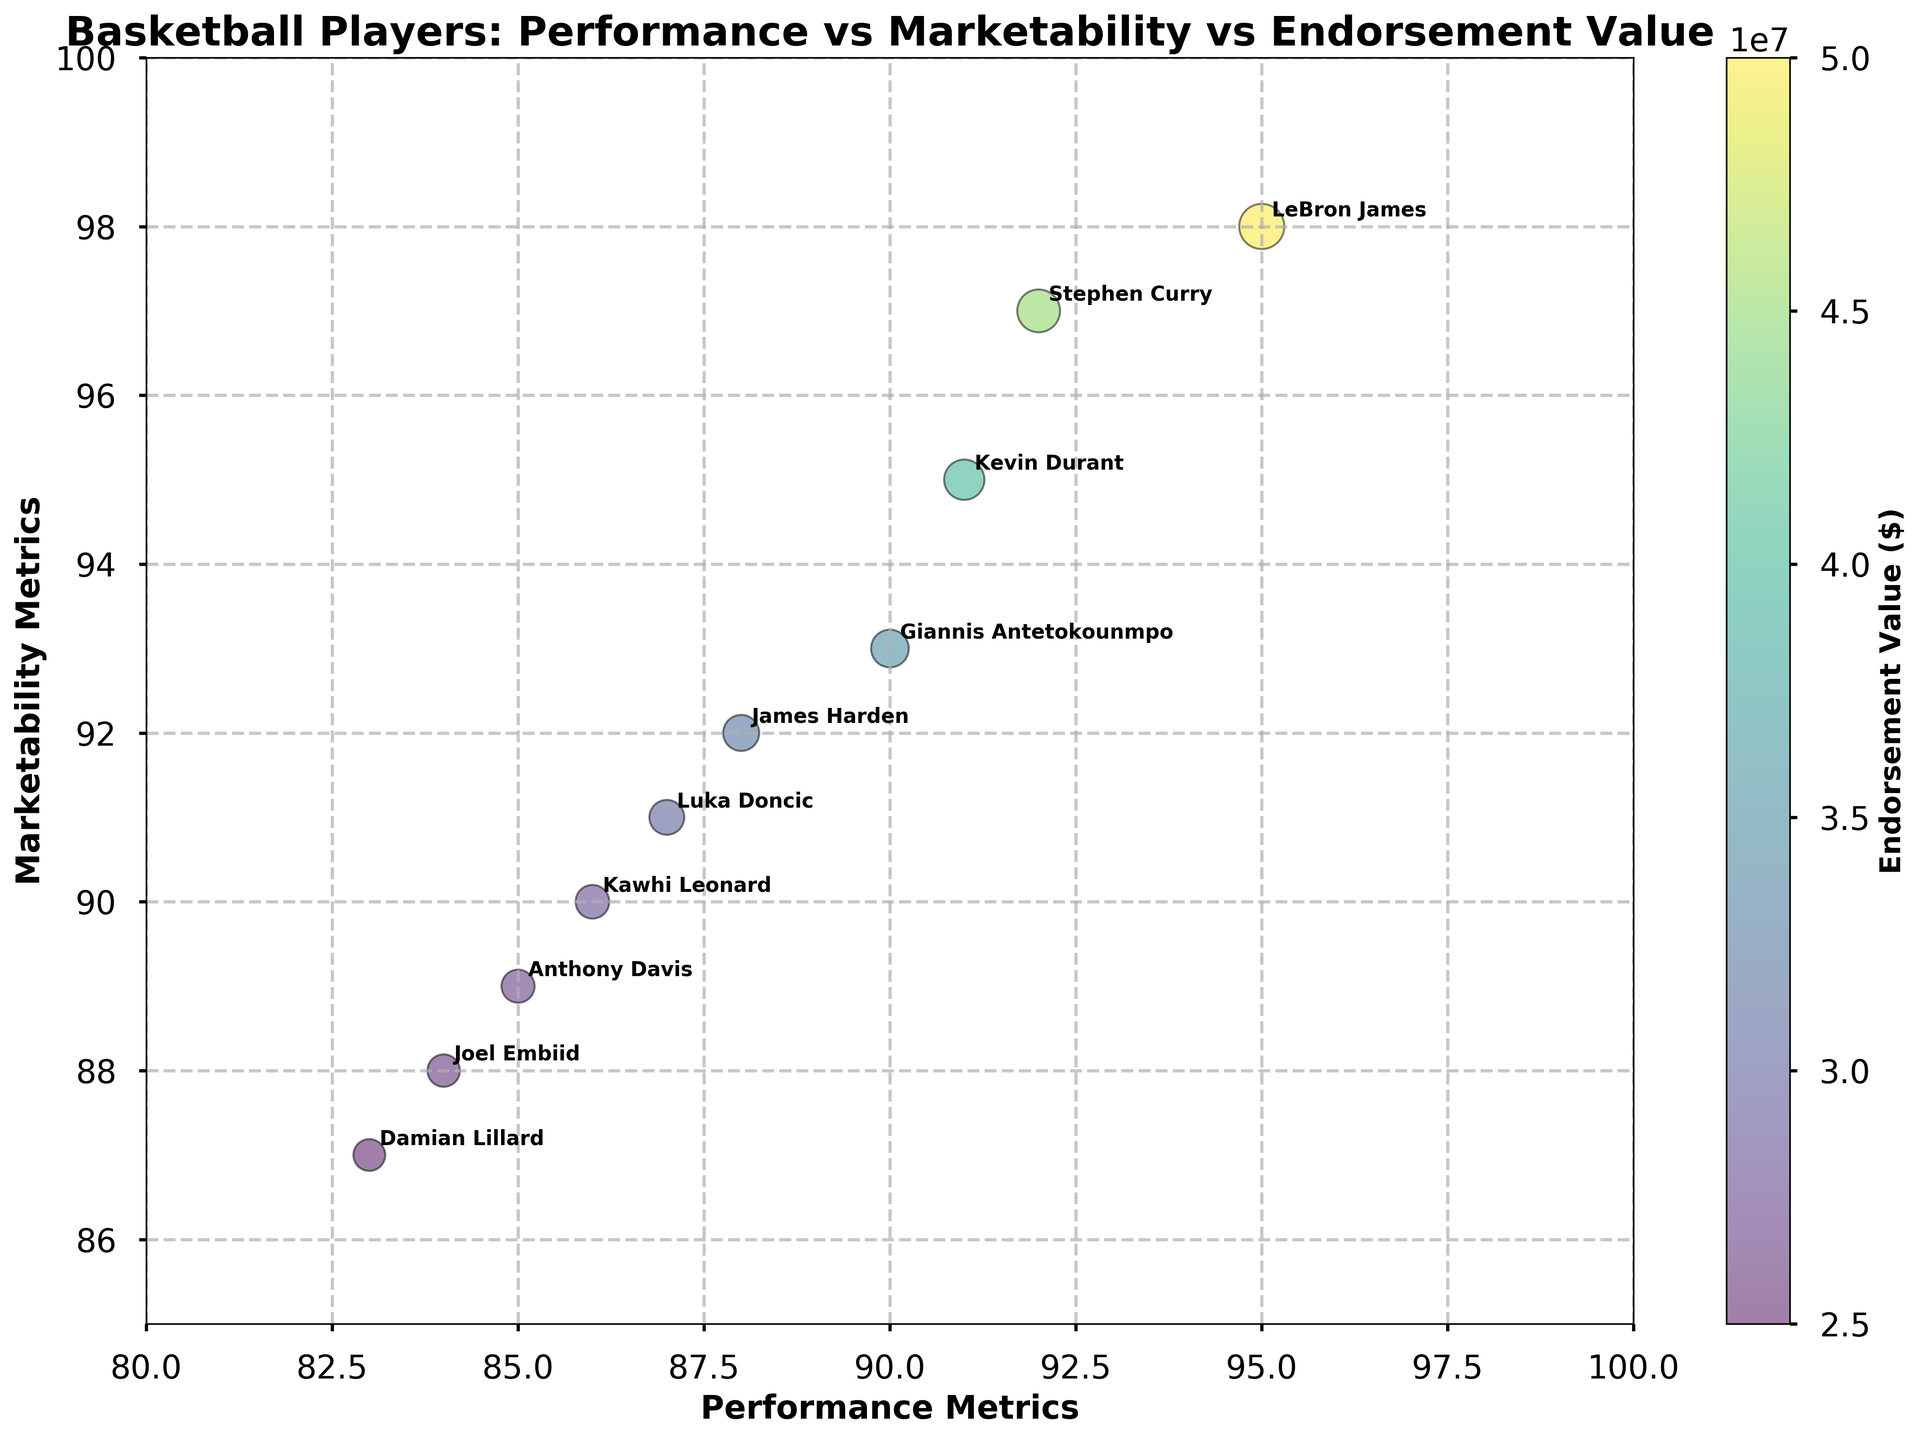What is the title of the chart? The title is typically located at the top of the chart, and in this case, it describes the main content or purpose of the visualization.
Answer: Basketball Players: Performance vs Marketability vs Endorsement Value Which player has the highest endorsement value? To determine this, look for the largest bubble in the chart since the size of the bubbles represents the endorsement value. Then, check the annotated name.
Answer: LeBron James What are the axis labels? Axis labels are placed along each axis and describe what each axis represents. For this chart, the x-axis and y-axis labels are located on the bottom and left side, respectively.
Answer: Performance Metrics and Marketability Metrics How many players have a performance metric greater than 90? Identify the bubbles with x-coordinates (performance metrics) greater than 90. Count these bubbles to obtain the result.
Answer: 4 Which player is positioned highest on the marketability metrics? The player with the highest marketability metric is found by identifying the bubble furthest up along the y-axis.
Answer: LeBron James What's the average endorsement value of the players? To find this, sum up all the endorsement values and then divide by the number of players: (50000000 + 45000000 + 40000000 + 35000000 + 32000000 + 30000000 + 28000000 + 27000000 + 26000000 + 25000000) / 10.
Answer: 33800000 How does the endorsement value of Stephen Curry compare to that of Kevin Durant? Examine the sizes of the bubbles for Stephen Curry and Kevin Durant. Stephen Curry’s bubble is slightly larger than Kevin Durant's, indicating he has a higher endorsement value.
Answer: Stephen Curry has a higher endorsement value Which player has the lowest combination of performance and marketability metrics? Look for the bubble that is closest to the origin (lowest x and y coordinates). In this case, it indicates the player with the smallest sum of performance and marketability metrics.
Answer: Damian Lillard What is the range of marketability metrics among the players? Identify the highest and lowest y-coordinates (marketability metrics) and then subtract the smallest value from the largest value.
Answer: 98 - 87 = 11 What is represented by the color of the bubbles? The color gradient of the bubbles, shown by the color bar, typically represents the endorsement value of the players.
Answer: Endorsement Value ($) 